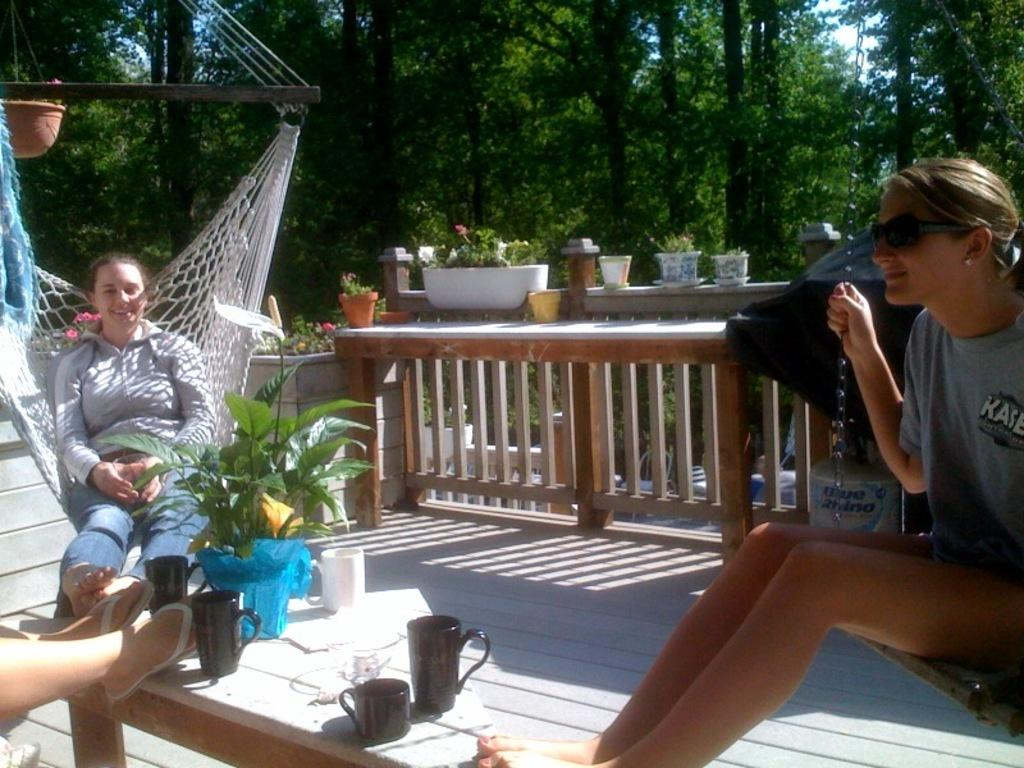What is present in the image that can be used for catching or holding objects? There is a net in the image. What type of living organism can be seen in the image? There is a plant in the image. How many people are visible in the image? There are two people in the image. What can be seen in the background of the image? There are trees in the background of the image. What piece of furniture is present in the image? There is a table in the image. What items are on the table? There are cups and another plant on the table. What object is also on the table? There is a pot on the table. What type of curtain can be seen hanging from the tree in the image? There is no curtain present in the image; only a net, a plant, two people, trees in the background, a table, cups, another plant, and a pot are visible. How does the earth appear in the image? The image does not show the earth; it features a net, a plant, two people, trees in the background, a table, cups, another plant, and a pot. 